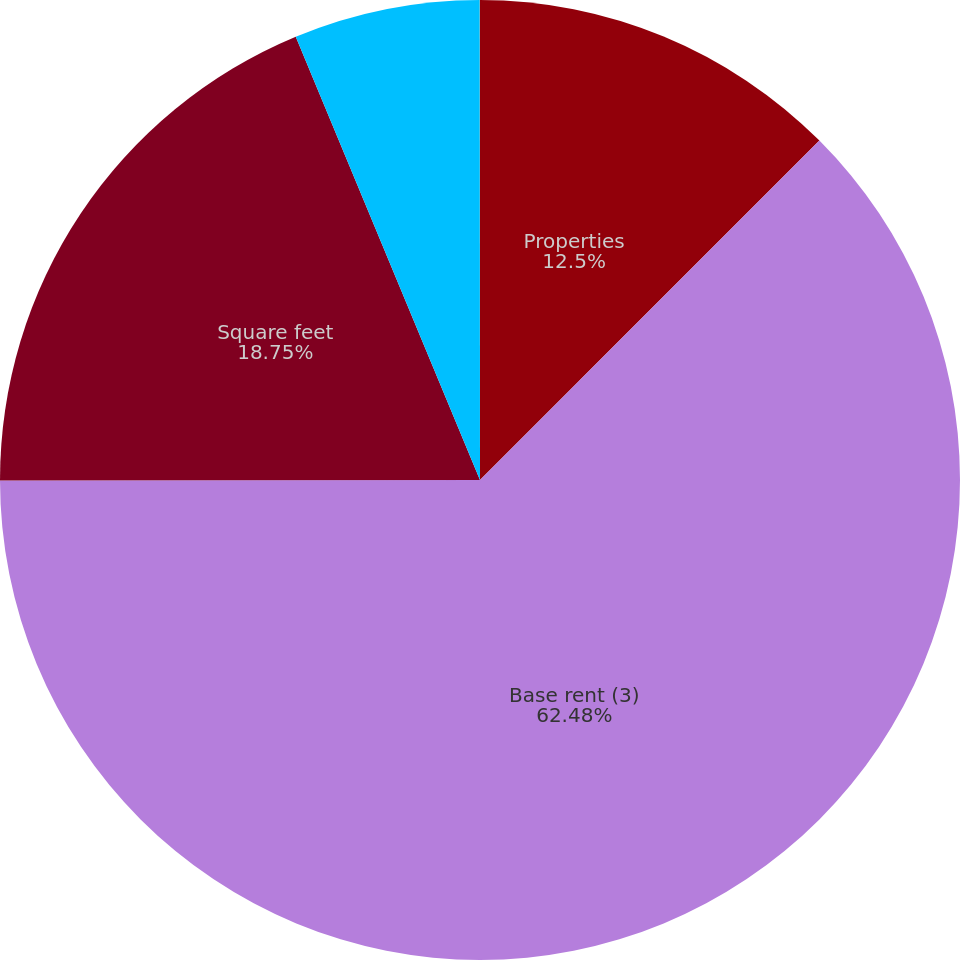<chart> <loc_0><loc_0><loc_500><loc_500><pie_chart><fcel>Properties<fcel>Base rent (3)<fcel>Square feet<fcel>of segment base rent<fcel>of total base rent<nl><fcel>12.5%<fcel>62.48%<fcel>18.75%<fcel>6.26%<fcel>0.01%<nl></chart> 